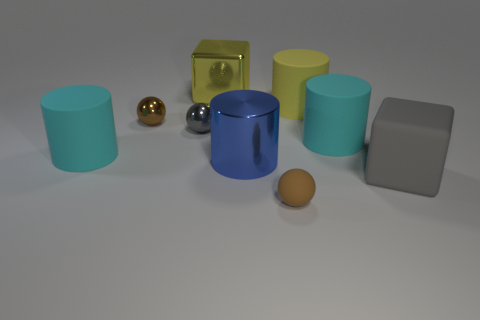There is a shiny thing that is the same size as the blue shiny cylinder; what is its color?
Your answer should be compact. Yellow. There is a tiny brown thing in front of the tiny gray metallic sphere; what material is it?
Your response must be concise. Rubber. There is a object that is both on the right side of the yellow rubber cylinder and in front of the blue metal cylinder; what is its material?
Give a very brief answer. Rubber. There is a gray thing left of the yellow cylinder; does it have the same size as the big shiny cube?
Make the answer very short. No. What shape is the blue thing?
Offer a very short reply. Cylinder. What number of cyan rubber things are the same shape as the blue thing?
Make the answer very short. 2. What number of large objects are left of the gray matte cube and to the right of the yellow metal cube?
Offer a very short reply. 3. The big metallic cylinder has what color?
Provide a succinct answer. Blue. Are there any cyan spheres that have the same material as the big yellow cylinder?
Make the answer very short. No. Are there any gray blocks in front of the big block behind the large cyan object on the left side of the metallic block?
Provide a short and direct response. Yes. 